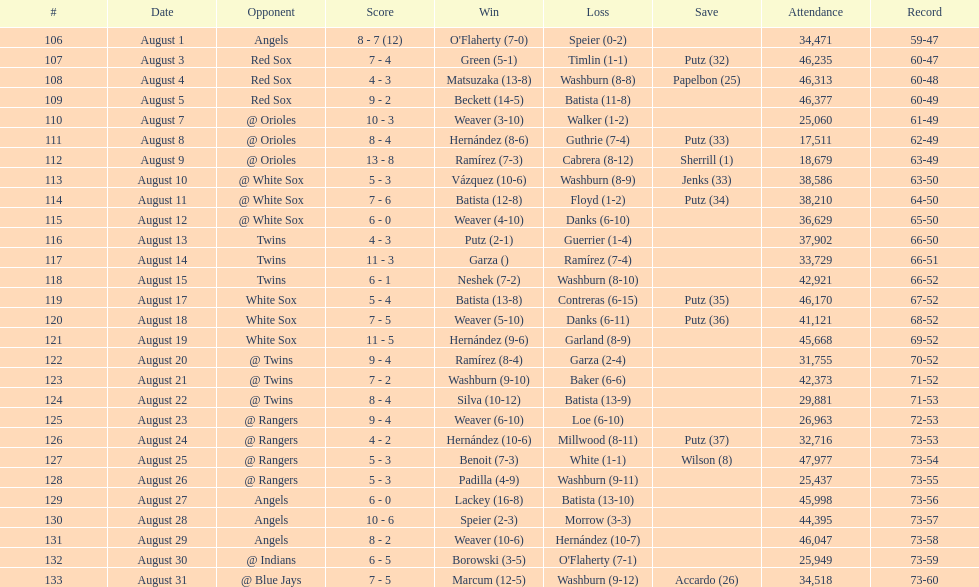What was the total number of games played in august 2007? 28. 